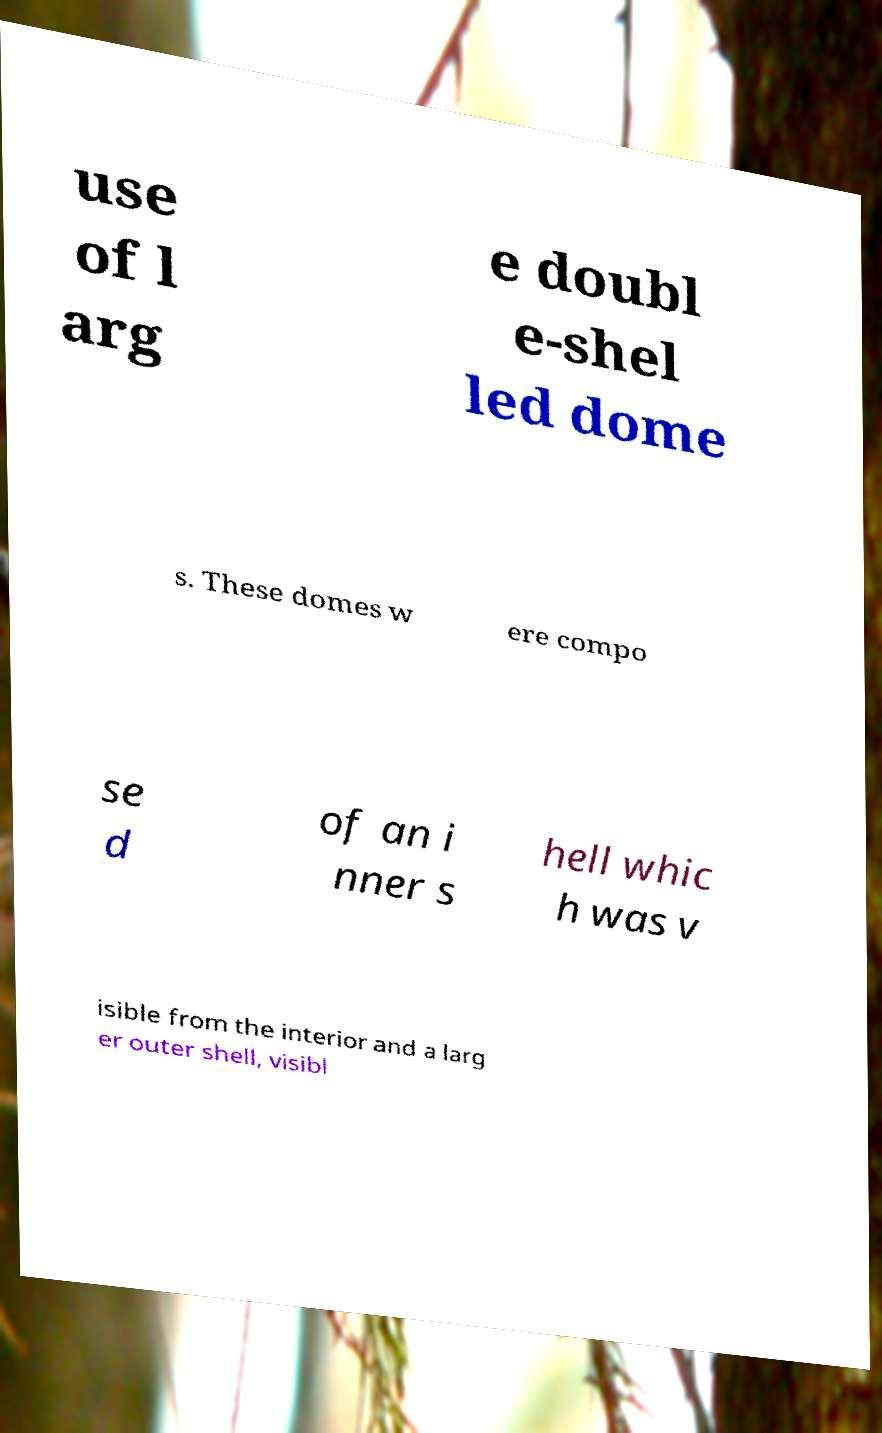Can you read and provide the text displayed in the image?This photo seems to have some interesting text. Can you extract and type it out for me? use of l arg e doubl e-shel led dome s. These domes w ere compo se d of an i nner s hell whic h was v isible from the interior and a larg er outer shell, visibl 